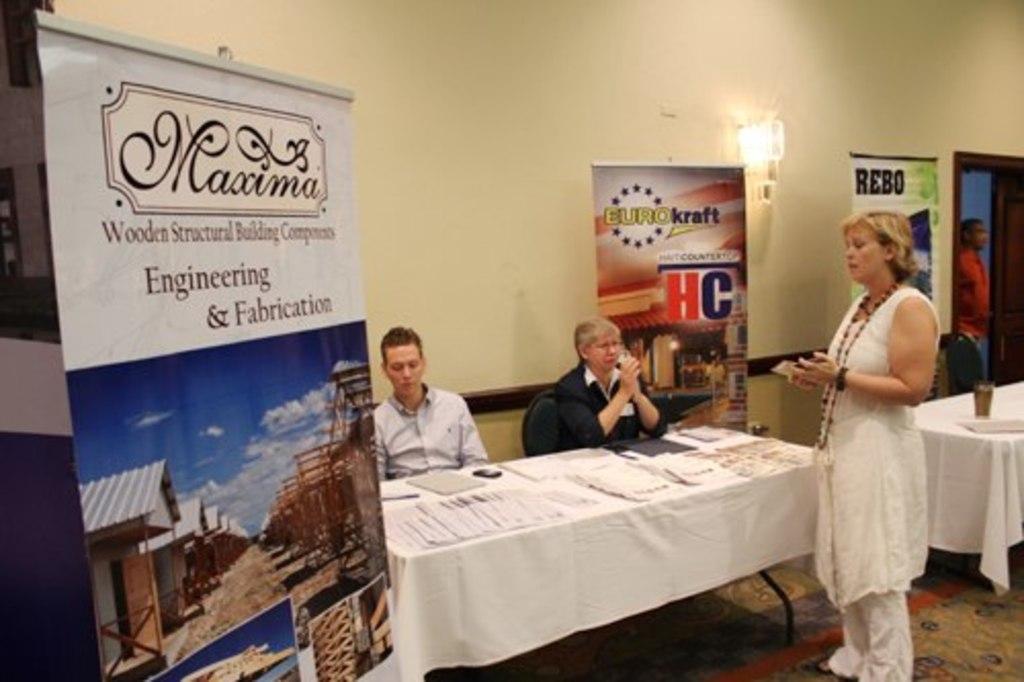Can you describe this image briefly? This image consists of a banner. To the right, there are three persons. In the front, there is a table which is covered with white cloth on which there are papers, and books along with a mobile are kept. In the background, there is a wall. At the bottom, there is floor. To the right, the woman is wearing white dress. 